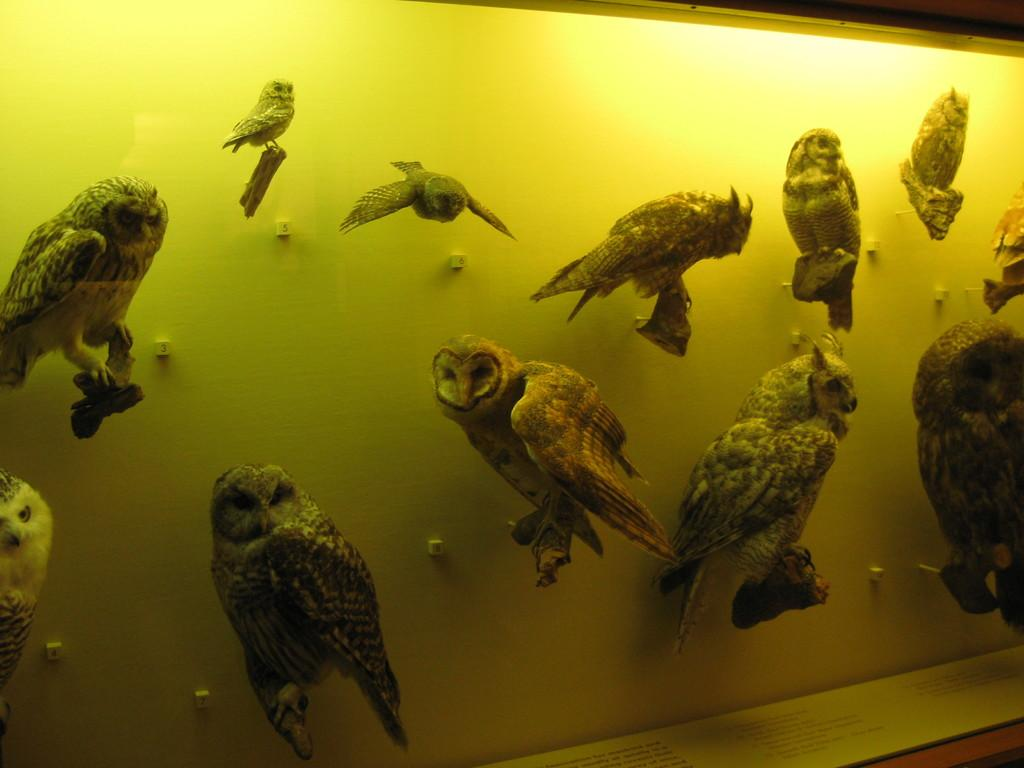What type of animals are depicted in the image? There are depictions of birds in the image. What can be seen in the background of the image? There is a wall in the background of the image. What is your sister doing with the spade in the image? There is no mention of a sister or a spade in the image; it only features depictions of birds and a wall in the background. 